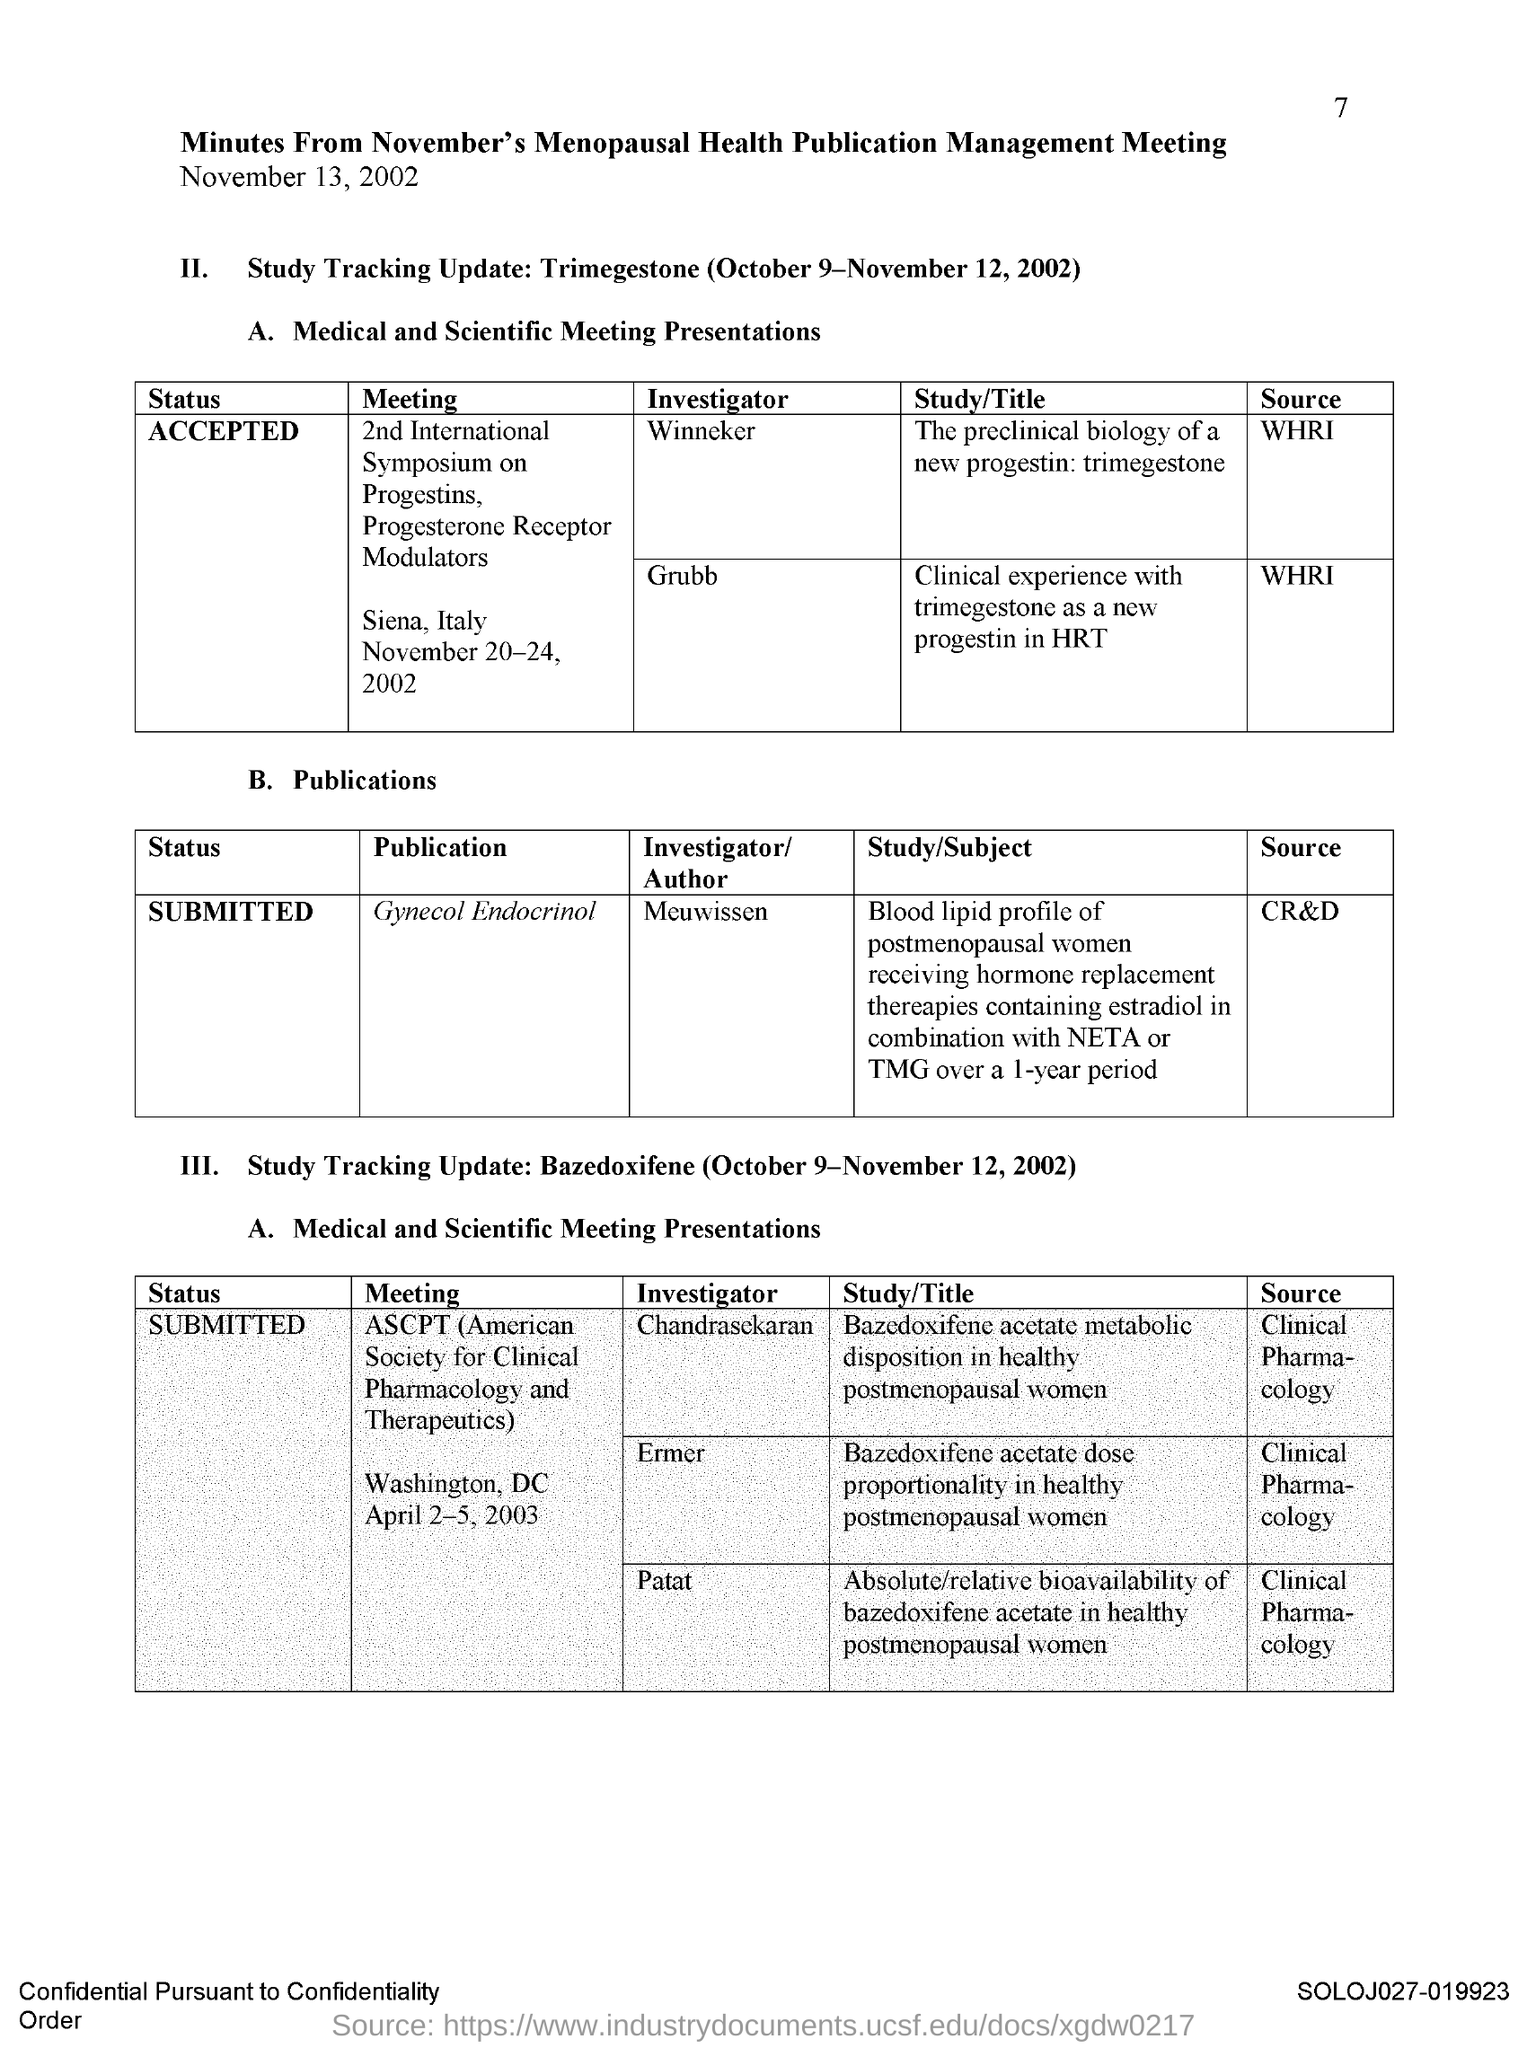Who is the Investigator of Gynecol Endocrinol?
Ensure brevity in your answer.  Meuwissen. 